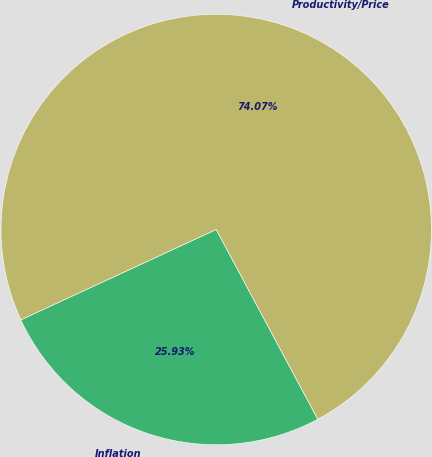Convert chart. <chart><loc_0><loc_0><loc_500><loc_500><pie_chart><fcel>Inflation<fcel>Productivity/Price<nl><fcel>25.93%<fcel>74.07%<nl></chart> 